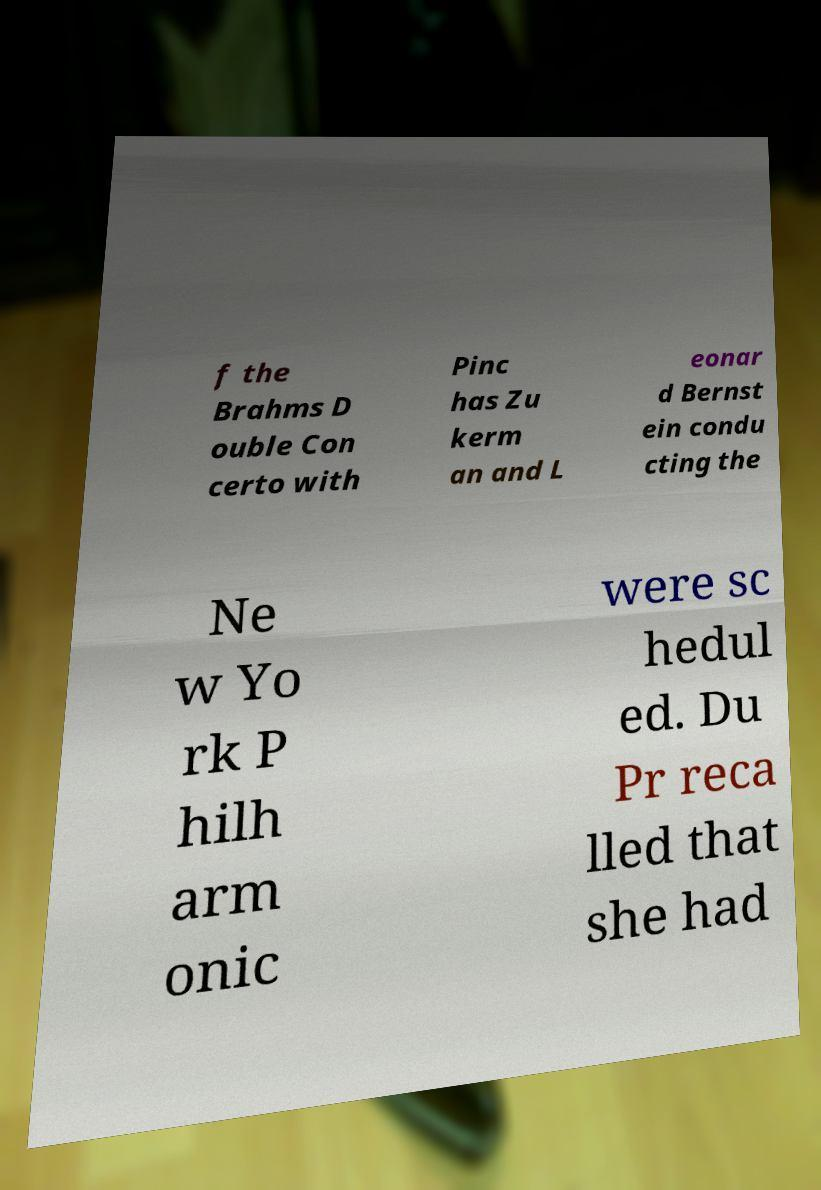Please identify and transcribe the text found in this image. f the Brahms D ouble Con certo with Pinc has Zu kerm an and L eonar d Bernst ein condu cting the Ne w Yo rk P hilh arm onic were sc hedul ed. Du Pr reca lled that she had 